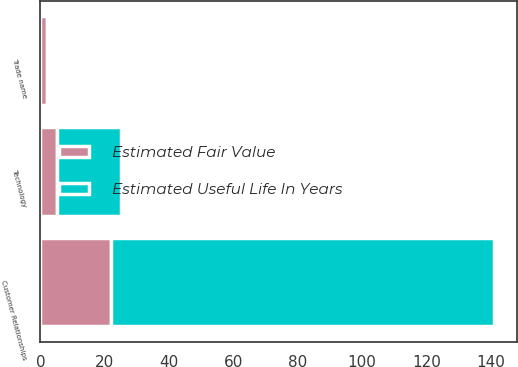<chart> <loc_0><loc_0><loc_500><loc_500><stacked_bar_chart><ecel><fcel>Customer Relationships<fcel>Technology<fcel>Trade name<nl><fcel>Estimated Useful Life In Years<fcel>119<fcel>20<fcel>1<nl><fcel>Estimated Fair Value<fcel>22<fcel>5<fcel>2<nl></chart> 